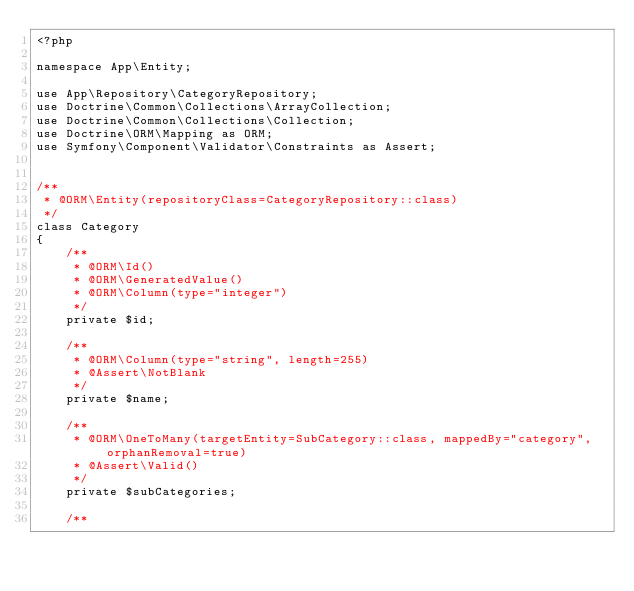Convert code to text. <code><loc_0><loc_0><loc_500><loc_500><_PHP_><?php

namespace App\Entity;

use App\Repository\CategoryRepository;
use Doctrine\Common\Collections\ArrayCollection;
use Doctrine\Common\Collections\Collection;
use Doctrine\ORM\Mapping as ORM;
use Symfony\Component\Validator\Constraints as Assert;


/**
 * @ORM\Entity(repositoryClass=CategoryRepository::class)
 */
class Category
{
    /**
     * @ORM\Id()
     * @ORM\GeneratedValue()
     * @ORM\Column(type="integer")
     */
    private $id;

    /**
     * @ORM\Column(type="string", length=255)
     * @Assert\NotBlank
     */
    private $name;

    /**
     * @ORM\OneToMany(targetEntity=SubCategory::class, mappedBy="category", orphanRemoval=true)
     * @Assert\Valid()
     */
    private $subCategories;

    /**</code> 